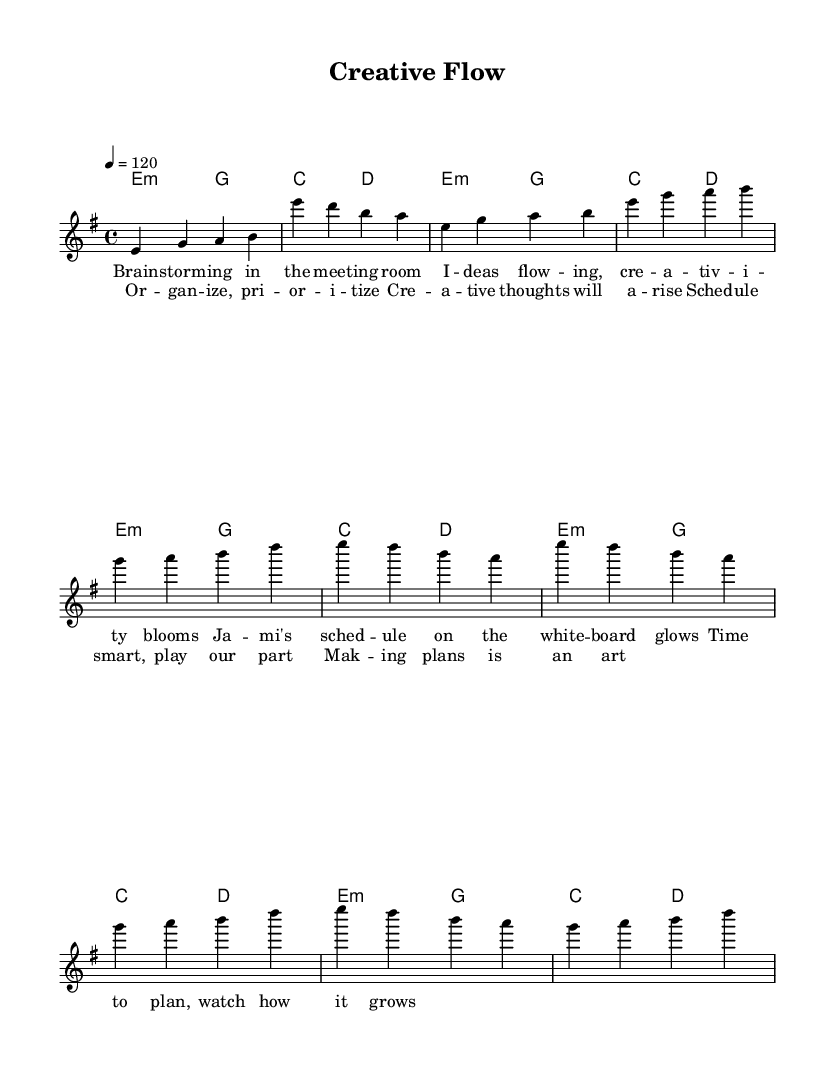What is the key signature of this music? The key signature is E minor, which has one sharp (F#). We can determine the key signature by looking for the sharp symbols in the sheet music near the beginning.
Answer: E minor What is the time signature of the piece? The time signature is 4/4, indicated at the beginning of the music. This means there are four beats in each measure and the quarter note gets one beat.
Answer: 4/4 What is the tempo marking provided in the score? The tempo marking is 120 beats per minute, which is indicated by "4 = 120" at the beginning of the piece. This tells us the speed of the music.
Answer: 120 How many measures are in the chorus section? The chorus section consists of 4 measures. By counting the measures in the provided melody for the chorus, we find four groups separated by vertical lines.
Answer: 4 Which chord is repeated throughout the harmonies? The repeated chord is E minor, as seen in the chord mode section where E minor appears multiple times. This establishes the harmonic foundation of the piece.
Answer: E minor What theme is present in the lyrics of the verse? The theme in the lyrics is brainstorming and scheduling, as it discusses ideas flowing and planning in a meeting room. This aligns with the creative aspect of the piece.
Answer: Brainstorming 